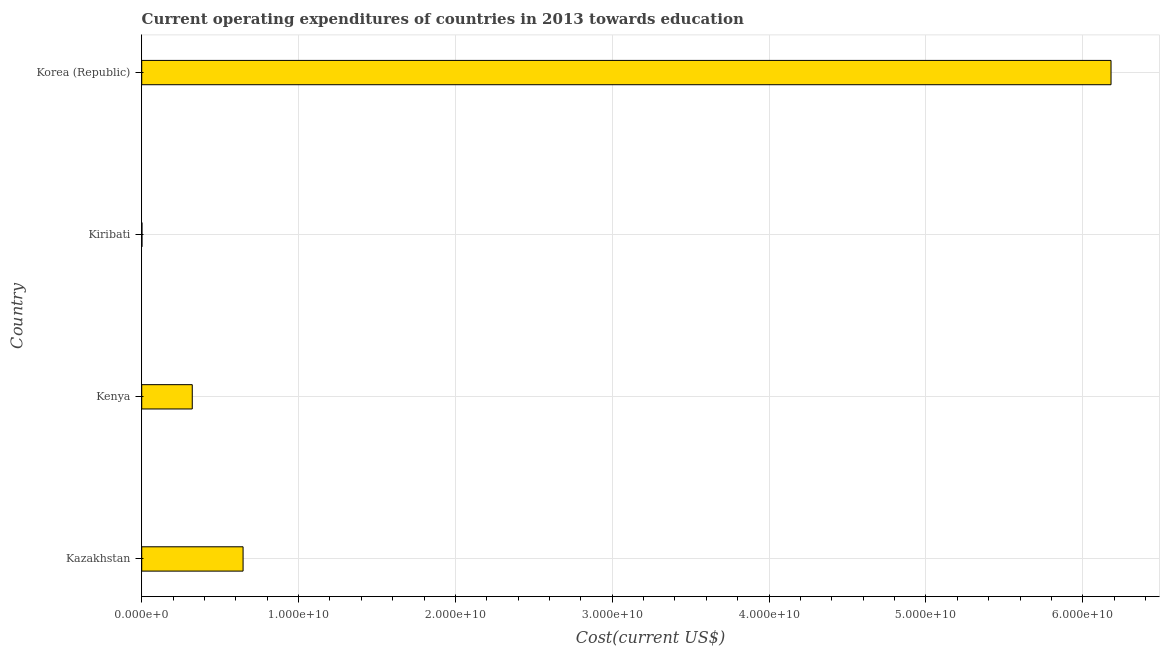What is the title of the graph?
Make the answer very short. Current operating expenditures of countries in 2013 towards education. What is the label or title of the X-axis?
Keep it short and to the point. Cost(current US$). What is the label or title of the Y-axis?
Keep it short and to the point. Country. What is the education expenditure in Kiribati?
Offer a terse response. 1.70e+07. Across all countries, what is the maximum education expenditure?
Give a very brief answer. 6.18e+1. Across all countries, what is the minimum education expenditure?
Your response must be concise. 1.70e+07. In which country was the education expenditure minimum?
Your answer should be very brief. Kiribati. What is the sum of the education expenditure?
Your answer should be very brief. 7.15e+1. What is the difference between the education expenditure in Kazakhstan and Kiribati?
Ensure brevity in your answer.  6.45e+09. What is the average education expenditure per country?
Provide a short and direct response. 1.79e+1. What is the median education expenditure?
Give a very brief answer. 4.84e+09. In how many countries, is the education expenditure greater than 62000000000 US$?
Provide a succinct answer. 0. What is the ratio of the education expenditure in Kenya to that in Kiribati?
Offer a very short reply. 189.36. What is the difference between the highest and the second highest education expenditure?
Offer a very short reply. 5.53e+1. What is the difference between the highest and the lowest education expenditure?
Give a very brief answer. 6.18e+1. In how many countries, is the education expenditure greater than the average education expenditure taken over all countries?
Your answer should be very brief. 1. Are all the bars in the graph horizontal?
Provide a succinct answer. Yes. How many countries are there in the graph?
Give a very brief answer. 4. What is the Cost(current US$) in Kazakhstan?
Offer a very short reply. 6.46e+09. What is the Cost(current US$) in Kenya?
Offer a terse response. 3.22e+09. What is the Cost(current US$) of Kiribati?
Provide a succinct answer. 1.70e+07. What is the Cost(current US$) of Korea (Republic)?
Provide a short and direct response. 6.18e+1. What is the difference between the Cost(current US$) in Kazakhstan and Kenya?
Keep it short and to the point. 3.24e+09. What is the difference between the Cost(current US$) in Kazakhstan and Kiribati?
Your answer should be compact. 6.45e+09. What is the difference between the Cost(current US$) in Kazakhstan and Korea (Republic)?
Your response must be concise. -5.53e+1. What is the difference between the Cost(current US$) in Kenya and Kiribati?
Your answer should be very brief. 3.21e+09. What is the difference between the Cost(current US$) in Kenya and Korea (Republic)?
Your answer should be compact. -5.86e+1. What is the difference between the Cost(current US$) in Kiribati and Korea (Republic)?
Offer a terse response. -6.18e+1. What is the ratio of the Cost(current US$) in Kazakhstan to that in Kenya?
Provide a succinct answer. 2. What is the ratio of the Cost(current US$) in Kazakhstan to that in Kiribati?
Keep it short and to the point. 379.74. What is the ratio of the Cost(current US$) in Kazakhstan to that in Korea (Republic)?
Ensure brevity in your answer.  0.1. What is the ratio of the Cost(current US$) in Kenya to that in Kiribati?
Provide a succinct answer. 189.36. What is the ratio of the Cost(current US$) in Kenya to that in Korea (Republic)?
Ensure brevity in your answer.  0.05. What is the ratio of the Cost(current US$) in Kiribati to that in Korea (Republic)?
Give a very brief answer. 0. 